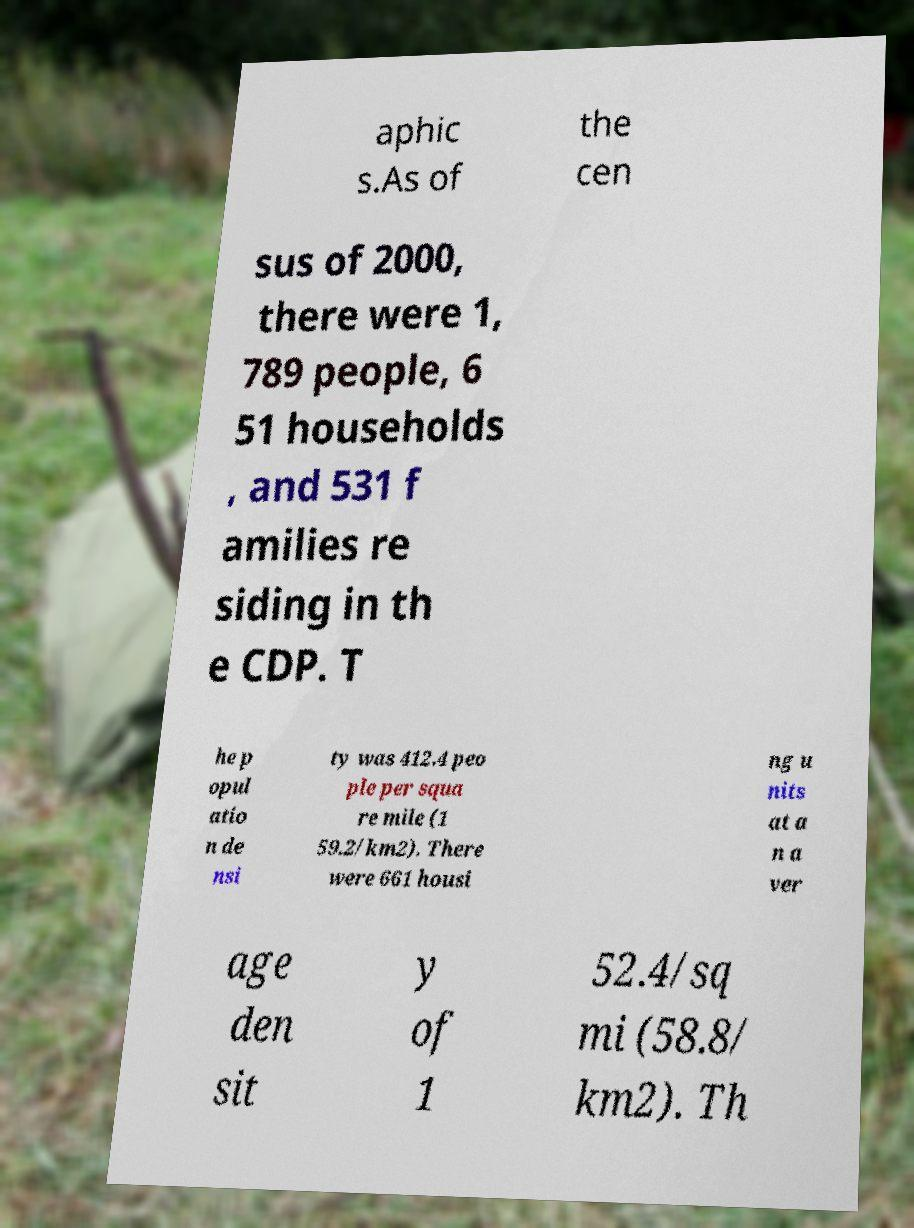I need the written content from this picture converted into text. Can you do that? aphic s.As of the cen sus of 2000, there were 1, 789 people, 6 51 households , and 531 f amilies re siding in th e CDP. T he p opul atio n de nsi ty was 412.4 peo ple per squa re mile (1 59.2/km2). There were 661 housi ng u nits at a n a ver age den sit y of 1 52.4/sq mi (58.8/ km2). Th 